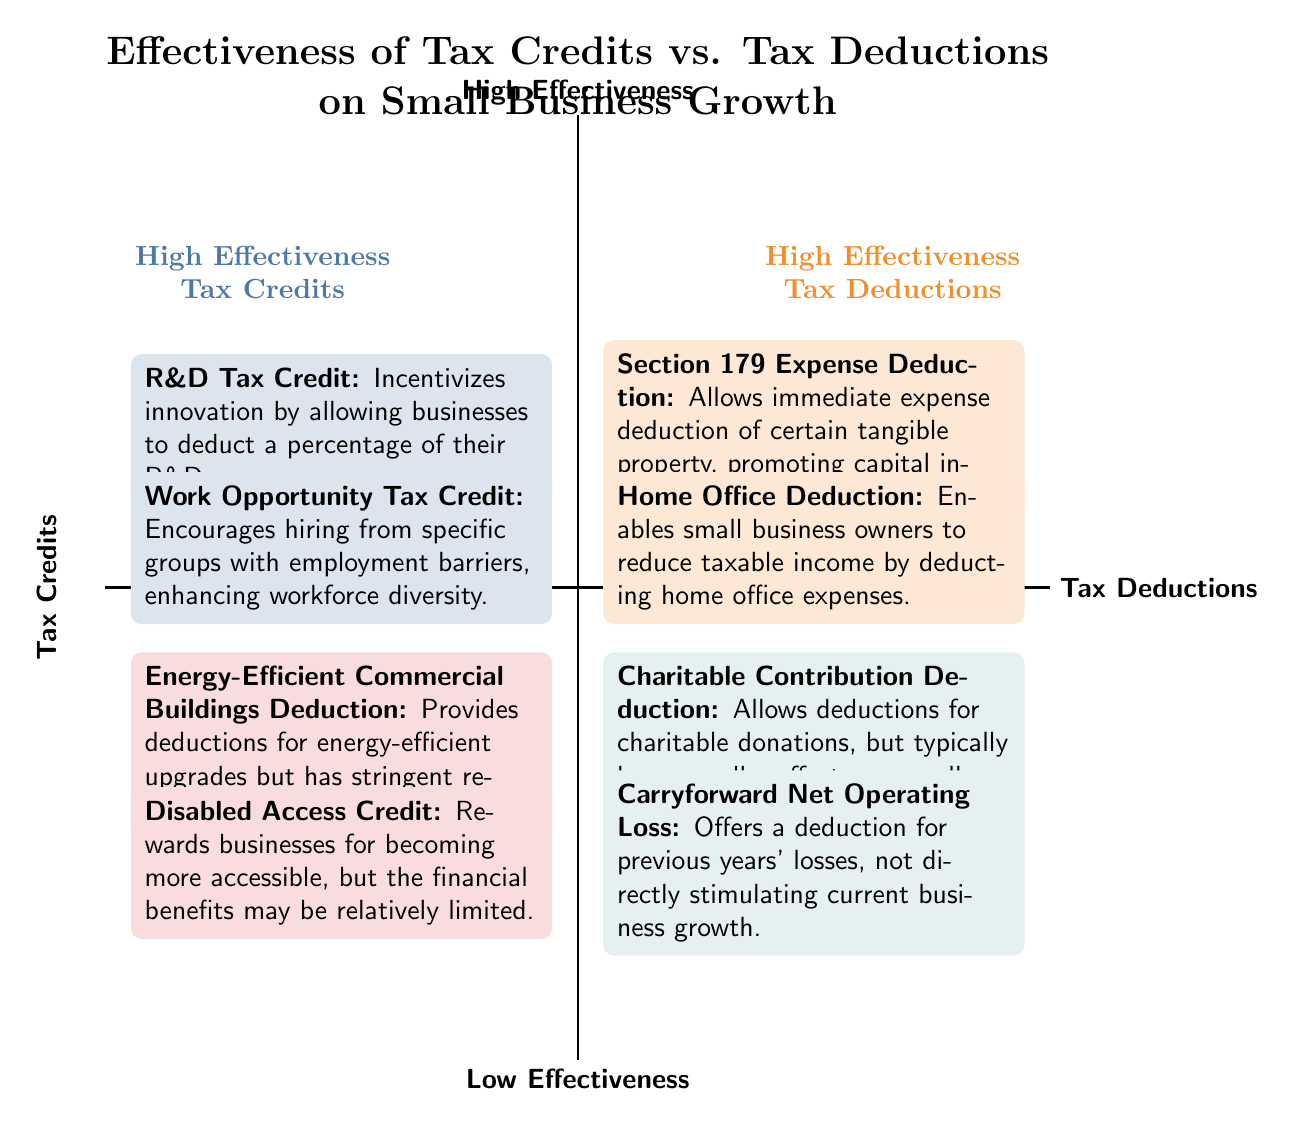What are the two elements in the "High Effectiveness Tax Credits" quadrant? The "High Effectiveness Tax Credits" quadrant contains two elements: "R&D Tax Credit" and "Work Opportunity Tax Credit". These are specifically located in the upper-left section of the diagram.
Answer: R&D Tax Credit, Work Opportunity Tax Credit Which quadrant contains the "Home Office Deduction"? The "Home Office Deduction" is found in the "High Effectiveness Tax Deductions" quadrant, which is located in the upper-right section of the diagram.
Answer: High Effectiveness Tax Deductions How many elements are positioned in the "Low Effectiveness Tax Credits" quadrant? The "Low Effectiveness Tax Credits" quadrant has two elements, which are explicitly listed within that section of the diagram.
Answer: 2 Which tax credit is described as having stringent requirements and moderate impact? The "Energy-Efficient Commercial Buildings Deduction" is described in the "Low Effectiveness Tax Credits" quadrant as having stringent requirements and moderate impact, clearly stated in its description.
Answer: Energy-Efficient Commercial Buildings Deduction In which quadrant would you find the "Section 179 Expense Deduction"? The "Section 179 Expense Deduction" is located in the "High Effectiveness Tax Deductions" quadrant, which is discernible in the upper-right portion of the diagram from the labeled category.
Answer: High Effectiveness Tax Deductions Which type of tax deduction allows for immediate expense deduction of certain tangible property? The "Section 179 Expense Deduction" allows for immediate expense deduction of certain tangible property and is fully described in the "High Effectiveness Tax Deductions" quadrant.
Answer: Section 179 Expense Deduction What is the general effect of the "Charitable Contribution Deduction" on overall business growth? The "Charitable Contribution Deduction" is stated to typically have a smaller effect on overall business growth, as indicated in its position within the "Low Effectiveness Tax Deductions" quadrant.
Answer: Smaller effect Which quadrant contains tax incentives that are likely to promote workforce diversity? The "High Effectiveness Tax Credits" quadrant contains the "Work Opportunity Tax Credit", which is designed to promote workforce diversity as stated in its description.
Answer: High Effectiveness Tax Credits What is the main purpose of the "Disabled Access Credit"? The main purpose of the "Disabled Access Credit" is to reward businesses for becoming more accessible, as described in the "Low Effectiveness Tax Credits" quadrant of the diagram.
Answer: Reward accessibility 